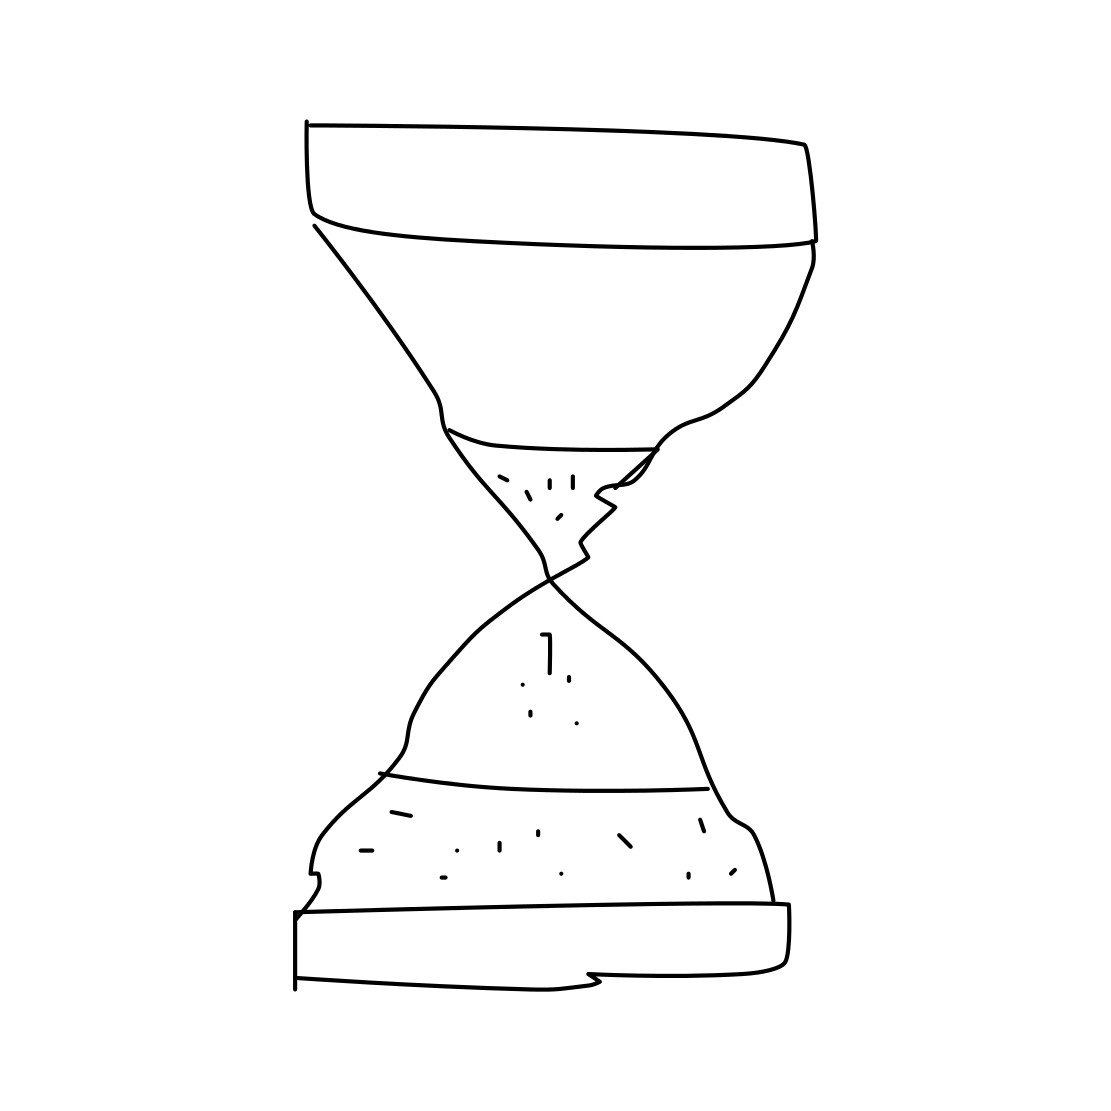Is this a hourglass in the image? Yes, the image shows a simple line drawing of a classic hourglass, which is an instrument used to measure the passage of time. It consists of two glass bulbs connected vertically by a narrow neck that allows sand to trickle from the upper to the lower bulb at a steady rate. 